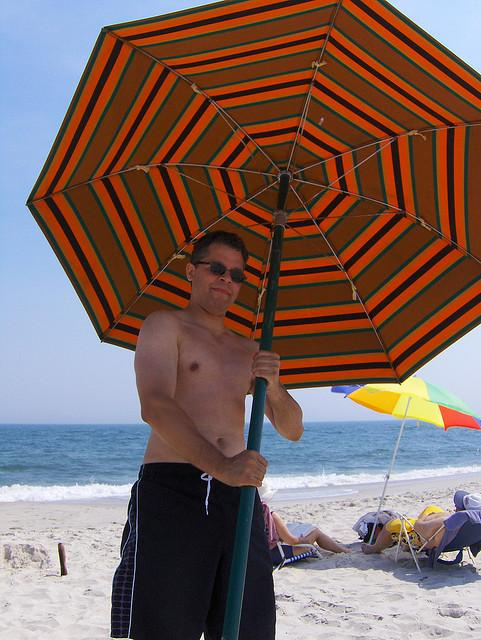If he is going to step out from under this structure he should put on what? Please explain your reasoning. sunblock. He is in the shade now but will need to protect himself with sunblock if he goes into the sun. 